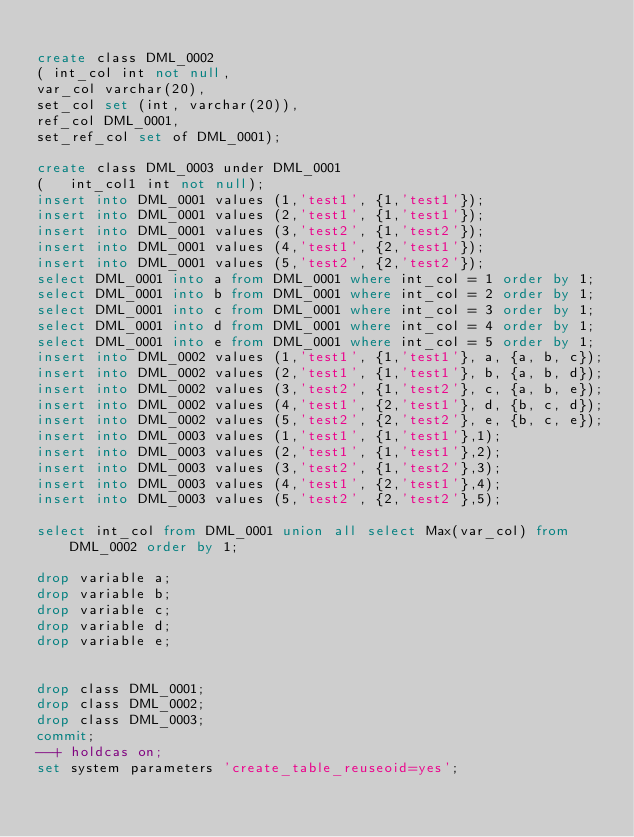<code> <loc_0><loc_0><loc_500><loc_500><_SQL_>
create class DML_0002 	
(	int_col int not null,
var_col varchar(20),
set_col set (int, varchar(20)),
ref_col DML_0001,
set_ref_col set of DML_0001);

create class DML_0003 under DML_0001
( 	int_col1 int not null);
insert into DML_0001 values (1,'test1', {1,'test1'});
insert into DML_0001 values (2,'test1', {1,'test1'});
insert into DML_0001 values (3,'test2', {1,'test2'});
insert into DML_0001 values (4,'test1', {2,'test1'});
insert into DML_0001 values (5,'test2', {2,'test2'});
select DML_0001 into a from DML_0001 where int_col = 1 order by 1;
select DML_0001 into b from DML_0001 where int_col = 2 order by 1;
select DML_0001 into c from DML_0001 where int_col = 3 order by 1;
select DML_0001 into d from DML_0001 where int_col = 4 order by 1;
select DML_0001 into e from DML_0001 where int_col = 5 order by 1;
insert into DML_0002 values (1,'test1', {1,'test1'}, a, {a, b, c});
insert into DML_0002 values (2,'test1', {1,'test1'}, b, {a, b, d});
insert into DML_0002 values (3,'test2', {1,'test2'}, c, {a, b, e});
insert into DML_0002 values (4,'test1', {2,'test1'}, d, {b, c, d});
insert into DML_0002 values (5,'test2', {2,'test2'}, e, {b, c, e});
insert into DML_0003 values (1,'test1', {1,'test1'},1);
insert into DML_0003 values (2,'test1', {1,'test1'},2);
insert into DML_0003 values (3,'test2', {1,'test2'},3);
insert into DML_0003 values (4,'test1', {2,'test1'},4);
insert into DML_0003 values (5,'test2', {2,'test2'},5);

select int_col from DML_0001 union all select Max(var_col) from DML_0002 order by 1;

drop variable a;
drop variable b;
drop variable c;
drop variable d;
drop variable e;


drop class DML_0001;
drop class DML_0002;
drop class DML_0003;
commit;
--+ holdcas on;
set system parameters 'create_table_reuseoid=yes';
</code> 